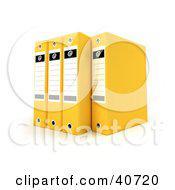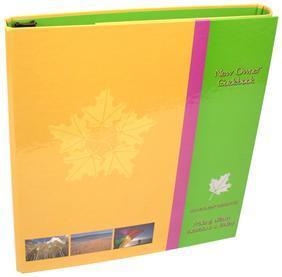The first image is the image on the left, the second image is the image on the right. Considering the images on both sides, is "There are four storage books of the same color in the left image." valid? Answer yes or no. Yes. 